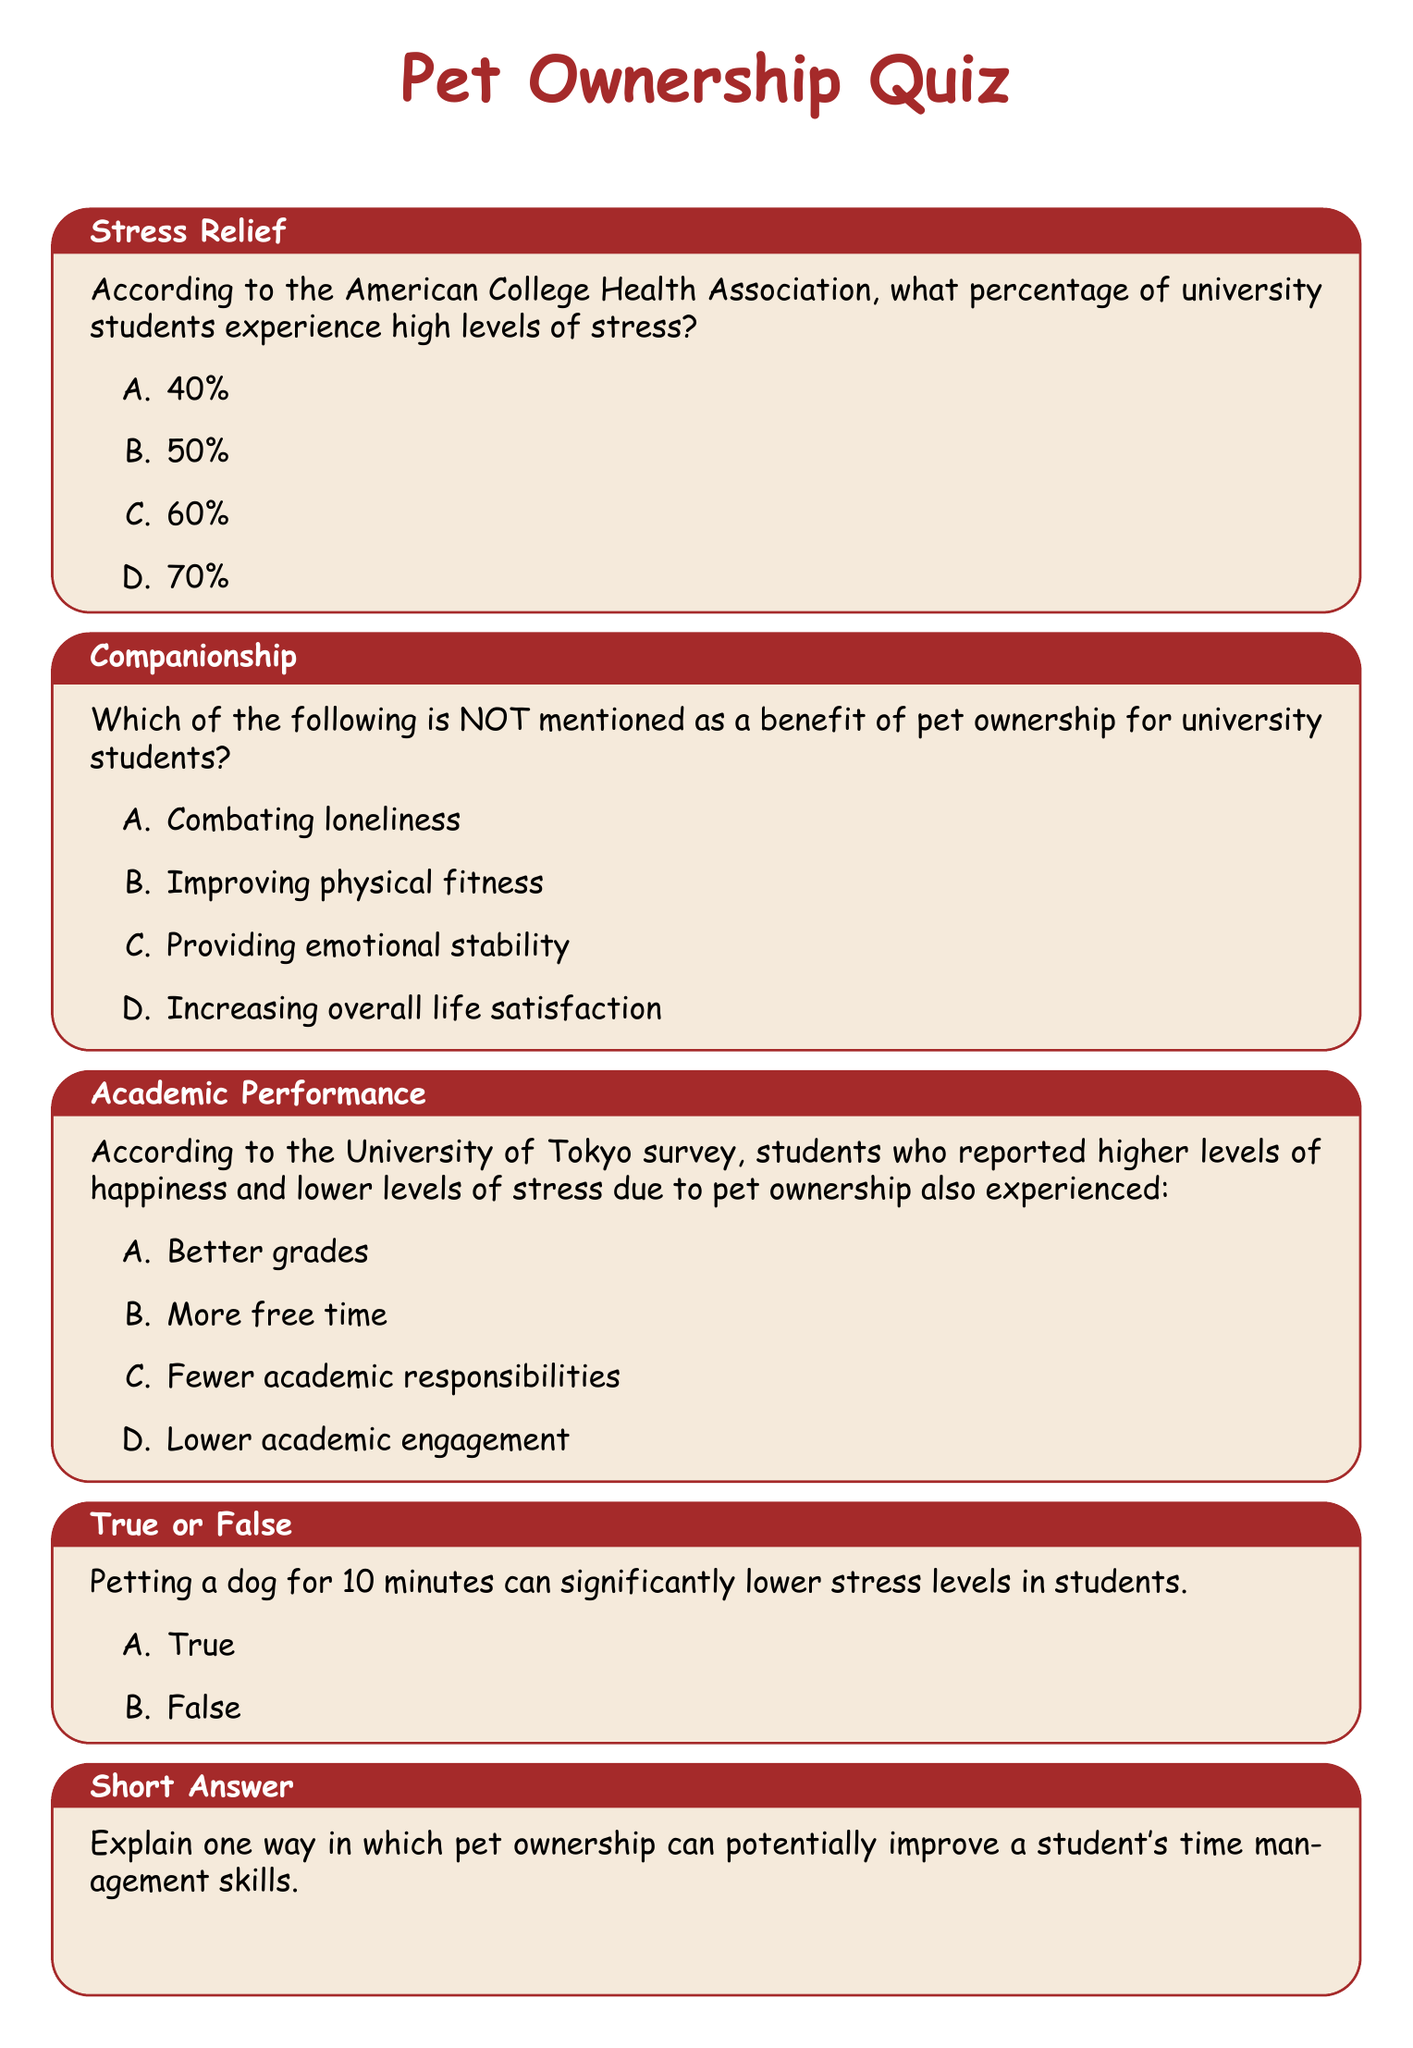What percentage of university students experience high levels of stress? According to the American College Health Association mentioned in the document, the percentage of university students experiencing high levels of stress is given as multiple-choice options.
Answer: 60% Which option is NOT a benefit of pet ownership for university students? The document lists several benefits of pet ownership; understanding which option is not mentioned requires reasoning based on the provided benefits.
Answer: Improving physical fitness What is the effect of pet ownership on students’ grades according to the University of Tokyo survey? The University of Tokyo survey noted the impact of pet ownership on happiness, stress levels, and consequently, students' academic performance, which relates to grades.
Answer: Better grades How long can petting a dog significantly lower stress levels in students? The document states that petting a dog for a specific duration can lower stress levels, which is a direct retrieval of information.
Answer: 10 minutes What is the main theme of the quiz in the document? The overall focus of the quiz is centered around the effects of pet ownership on university students, highlighting aspects like stress relief and companionship.
Answer: Pet Ownership 